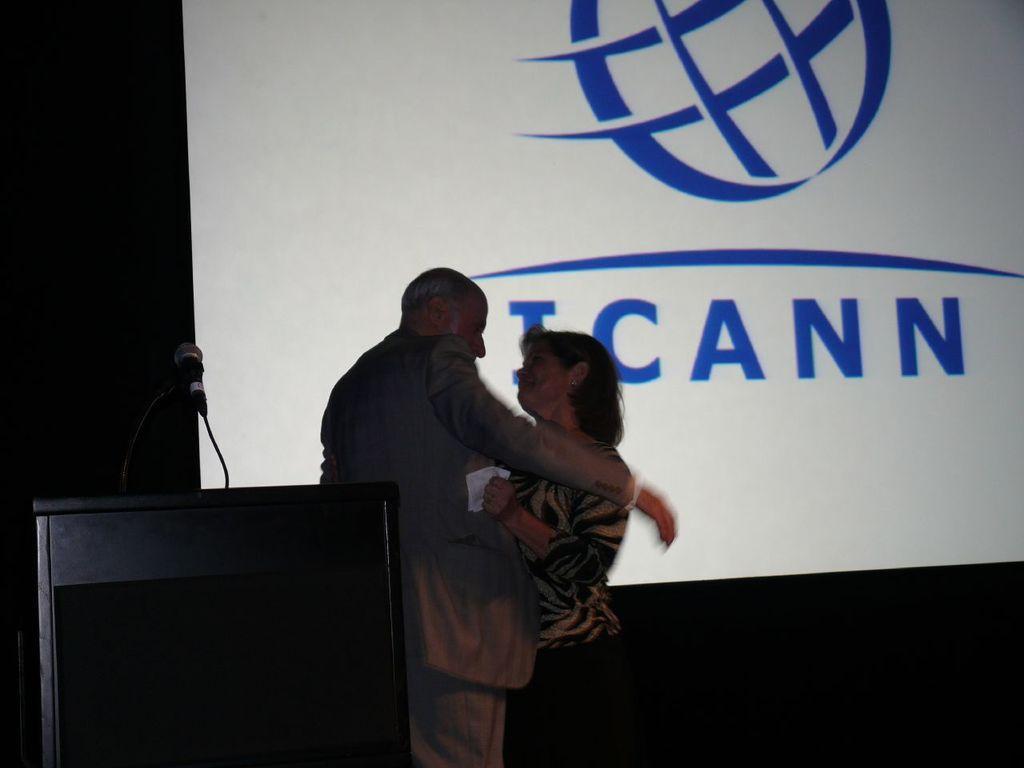Please provide a concise description of this image. In this image there is a man and a lady. Here there is a podium. On it there is a mic. In the background there is a screen. 